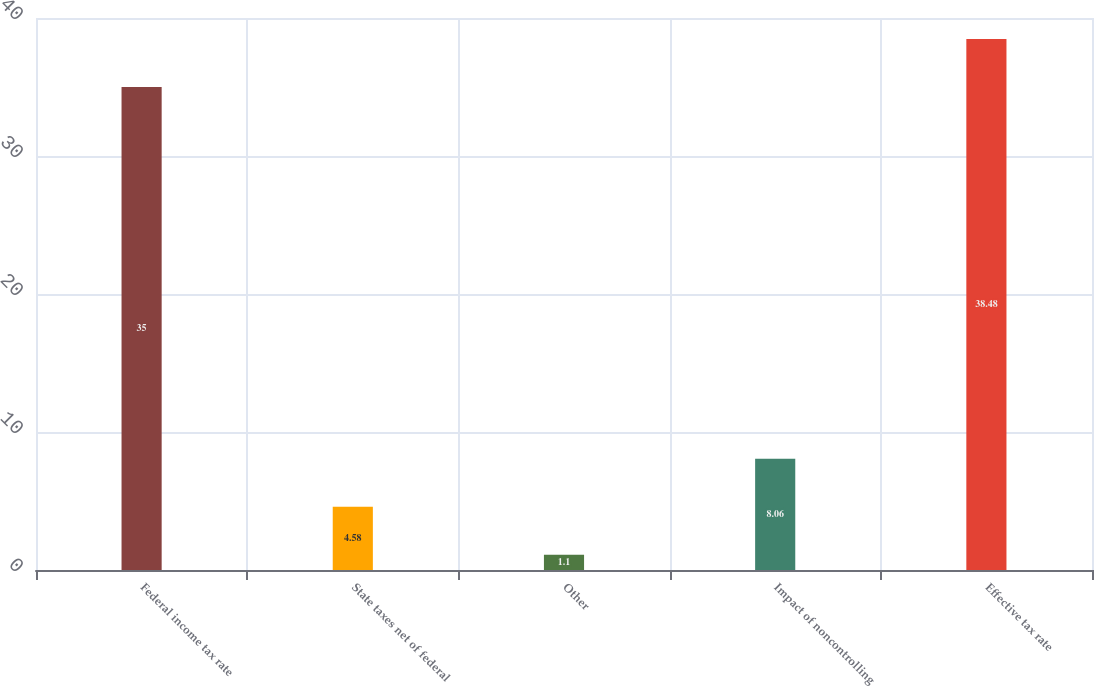Convert chart. <chart><loc_0><loc_0><loc_500><loc_500><bar_chart><fcel>Federal income tax rate<fcel>State taxes net of federal<fcel>Other<fcel>Impact of noncontrolling<fcel>Effective tax rate<nl><fcel>35<fcel>4.58<fcel>1.1<fcel>8.06<fcel>38.48<nl></chart> 